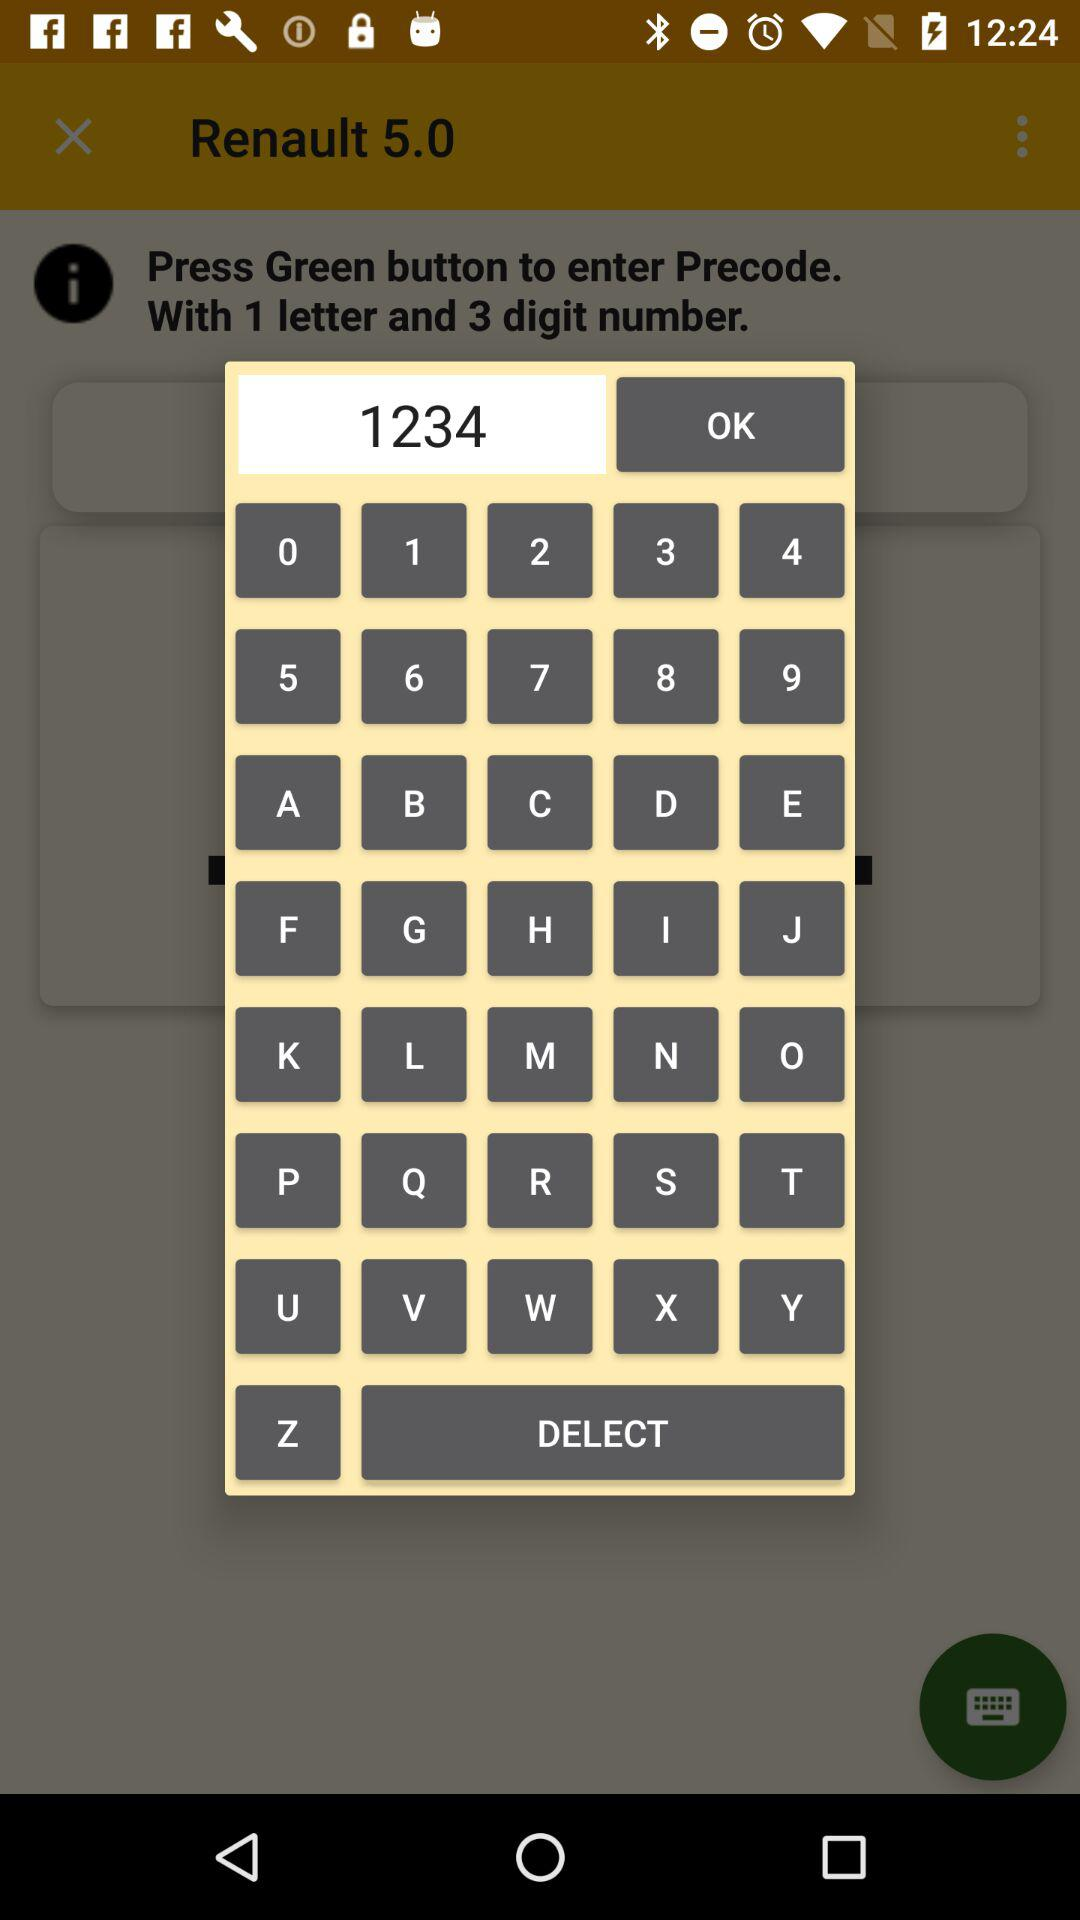What is the entered code? The entered code is "1234". 